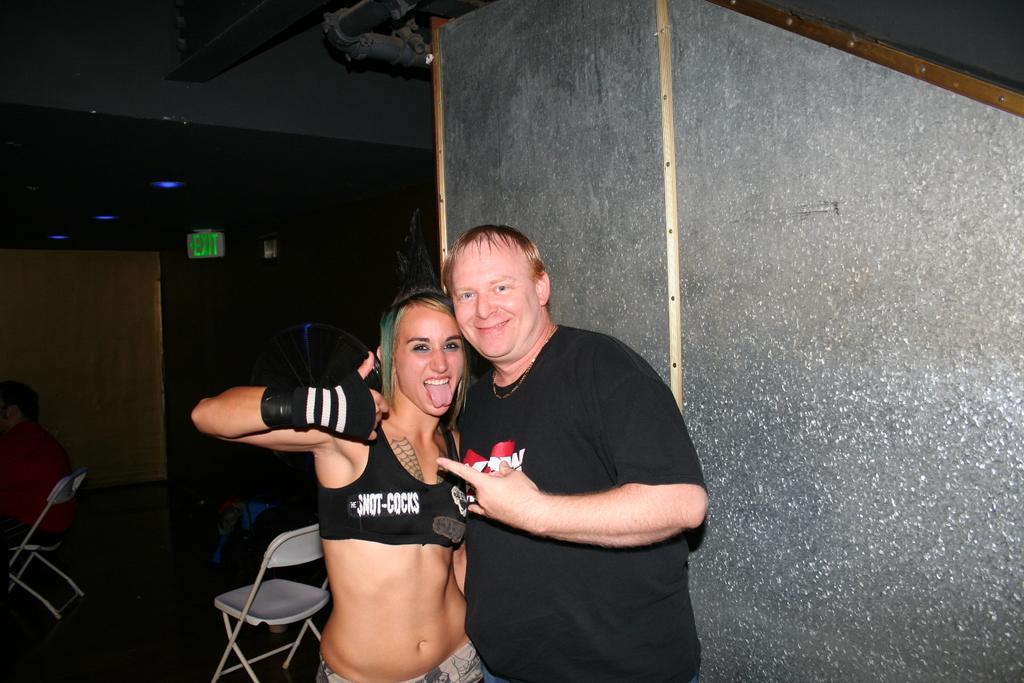Can you describe this image briefly? There are two people standing,beside these people we can see wall. In the background it is dark and we can see chairs,people and board. 